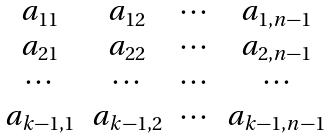<formula> <loc_0><loc_0><loc_500><loc_500>\begin{matrix} a _ { 1 1 } & a _ { 1 2 } & \cdots & a _ { 1 , n - 1 } \\ a _ { 2 1 } & a _ { 2 2 } & \cdots & a _ { 2 , n - 1 } \\ \cdots & \cdots & \cdots & \cdots \\ a _ { k - 1 , 1 } & a _ { k - 1 , 2 } & \cdots & a _ { k - 1 , n - 1 } \end{matrix}</formula> 